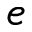<formula> <loc_0><loc_0><loc_500><loc_500>e</formula> 